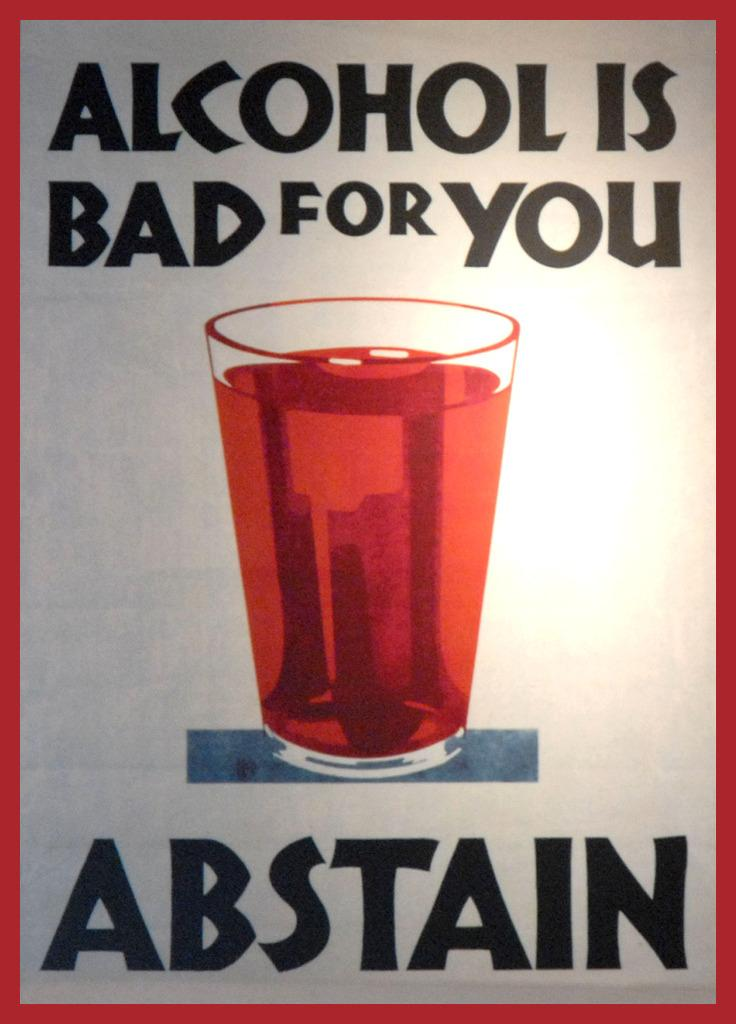<image>
Provide a brief description of the given image. A warning sign that says Alcohol is Bad for You, Abstain 